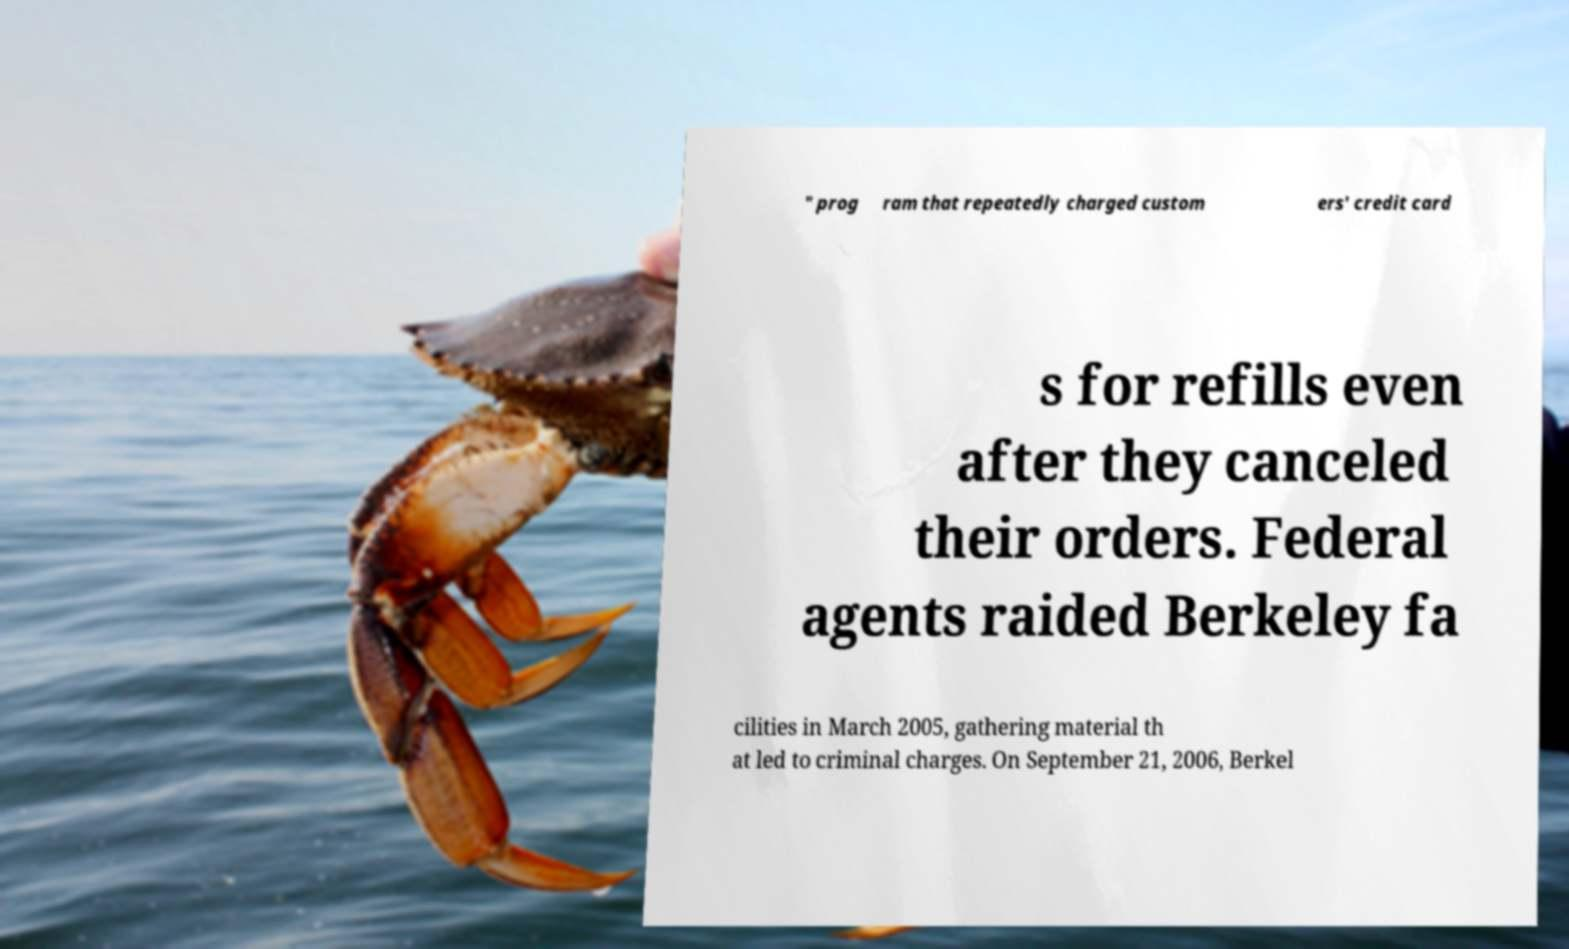Can you accurately transcribe the text from the provided image for me? " prog ram that repeatedly charged custom ers' credit card s for refills even after they canceled their orders. Federal agents raided Berkeley fa cilities in March 2005, gathering material th at led to criminal charges. On September 21, 2006, Berkel 